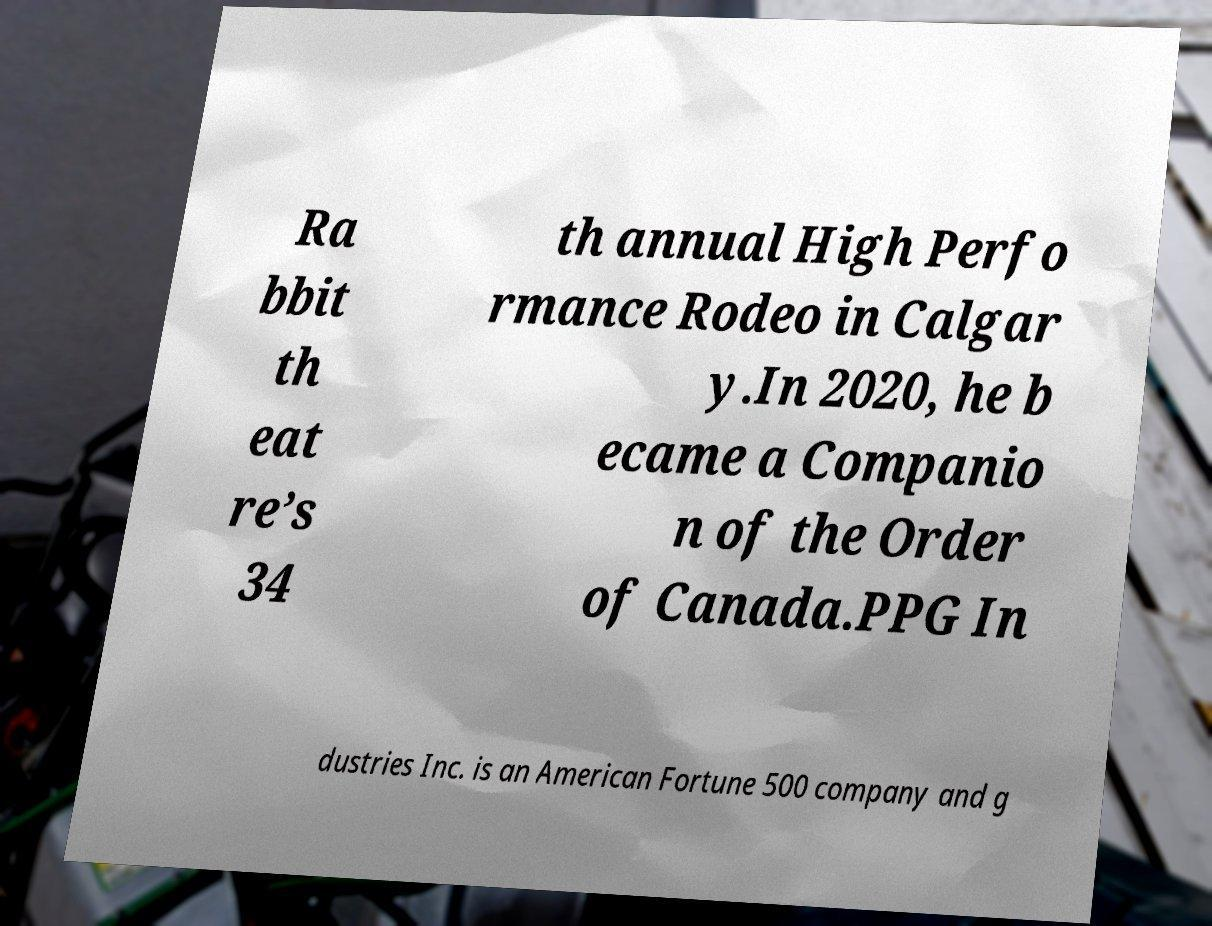What messages or text are displayed in this image? I need them in a readable, typed format. Ra bbit th eat re’s 34 th annual High Perfo rmance Rodeo in Calgar y.In 2020, he b ecame a Companio n of the Order of Canada.PPG In dustries Inc. is an American Fortune 500 company and g 